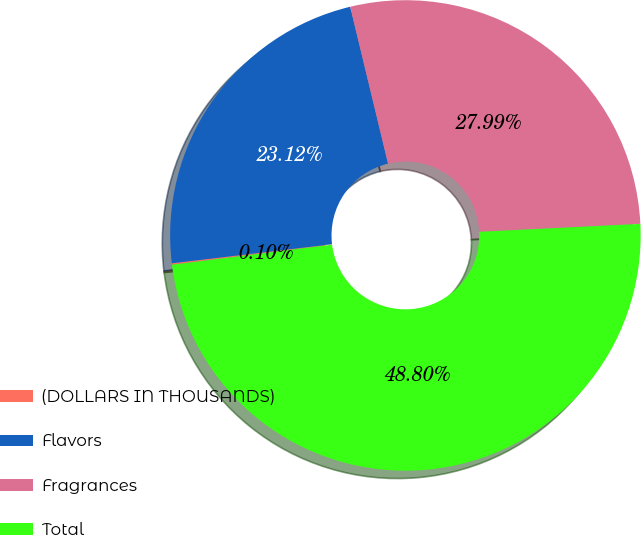Convert chart to OTSL. <chart><loc_0><loc_0><loc_500><loc_500><pie_chart><fcel>(DOLLARS IN THOUSANDS)<fcel>Flavors<fcel>Fragrances<fcel>Total<nl><fcel>0.1%<fcel>23.12%<fcel>27.99%<fcel>48.8%<nl></chart> 